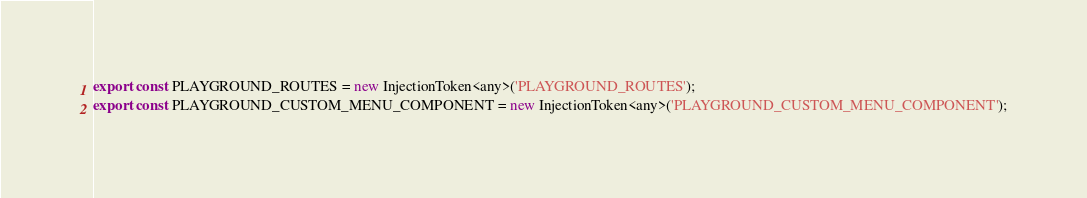<code> <loc_0><loc_0><loc_500><loc_500><_TypeScript_>
export const PLAYGROUND_ROUTES = new InjectionToken<any>('PLAYGROUND_ROUTES');
export const PLAYGROUND_CUSTOM_MENU_COMPONENT = new InjectionToken<any>('PLAYGROUND_CUSTOM_MENU_COMPONENT');
</code> 